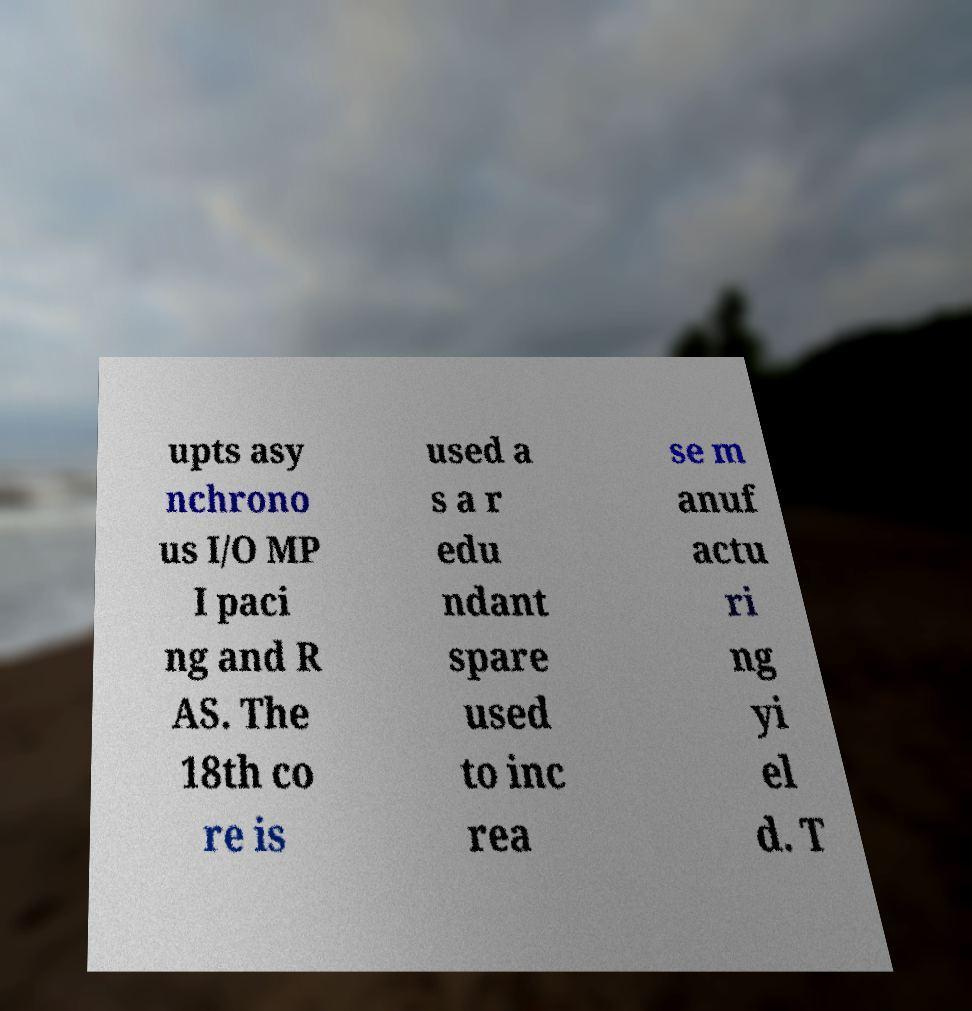Please identify and transcribe the text found in this image. upts asy nchrono us I/O MP I paci ng and R AS. The 18th co re is used a s a r edu ndant spare used to inc rea se m anuf actu ri ng yi el d. T 